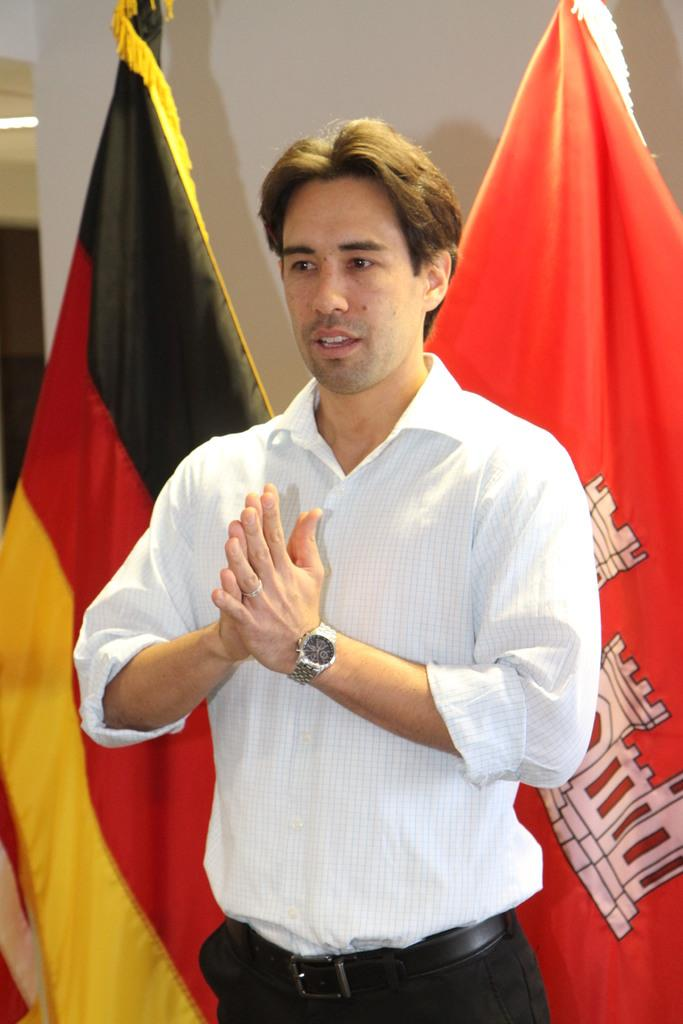Who is present in the image? There is a man in the image. What is the man wearing? The man is wearing a white shirt. Where is the man positioned in the image? The man is standing in the front of the image. What colors are the flags in the image? The flags visible in the image are red and black. What type of drink is the man holding in the image? There is no drink visible in the image; the man is not holding anything. 